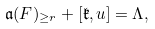<formula> <loc_0><loc_0><loc_500><loc_500>\mathfrak a ( F ) _ { \geq r } + [ \mathfrak k , u ] = \Lambda ,</formula> 